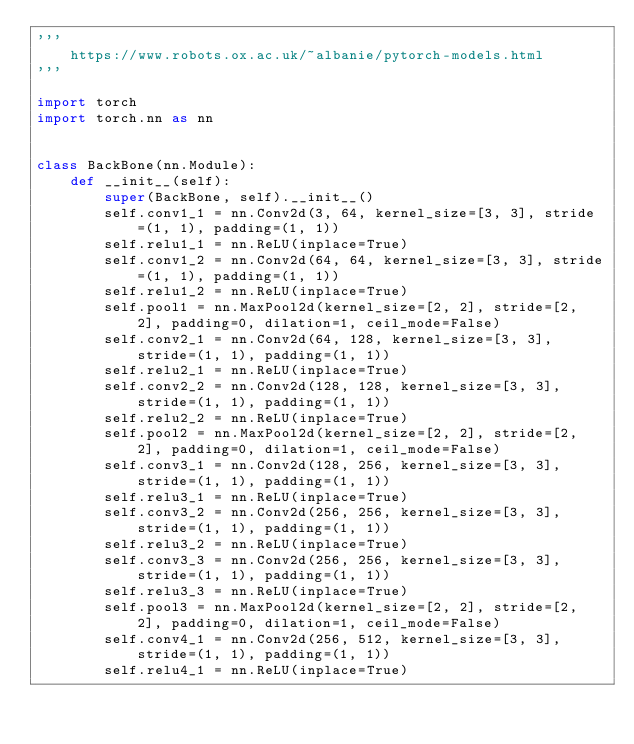Convert code to text. <code><loc_0><loc_0><loc_500><loc_500><_Python_>'''
    https://www.robots.ox.ac.uk/~albanie/pytorch-models.html
'''

import torch
import torch.nn as nn


class BackBone(nn.Module):
    def __init__(self):
        super(BackBone, self).__init__()
        self.conv1_1 = nn.Conv2d(3, 64, kernel_size=[3, 3], stride=(1, 1), padding=(1, 1))
        self.relu1_1 = nn.ReLU(inplace=True)
        self.conv1_2 = nn.Conv2d(64, 64, kernel_size=[3, 3], stride=(1, 1), padding=(1, 1))
        self.relu1_2 = nn.ReLU(inplace=True)
        self.pool1 = nn.MaxPool2d(kernel_size=[2, 2], stride=[2, 2], padding=0, dilation=1, ceil_mode=False)
        self.conv2_1 = nn.Conv2d(64, 128, kernel_size=[3, 3], stride=(1, 1), padding=(1, 1))
        self.relu2_1 = nn.ReLU(inplace=True)
        self.conv2_2 = nn.Conv2d(128, 128, kernel_size=[3, 3], stride=(1, 1), padding=(1, 1))
        self.relu2_2 = nn.ReLU(inplace=True)
        self.pool2 = nn.MaxPool2d(kernel_size=[2, 2], stride=[2, 2], padding=0, dilation=1, ceil_mode=False)
        self.conv3_1 = nn.Conv2d(128, 256, kernel_size=[3, 3], stride=(1, 1), padding=(1, 1))
        self.relu3_1 = nn.ReLU(inplace=True)
        self.conv3_2 = nn.Conv2d(256, 256, kernel_size=[3, 3], stride=(1, 1), padding=(1, 1))
        self.relu3_2 = nn.ReLU(inplace=True)
        self.conv3_3 = nn.Conv2d(256, 256, kernel_size=[3, 3], stride=(1, 1), padding=(1, 1))
        self.relu3_3 = nn.ReLU(inplace=True)
        self.pool3 = nn.MaxPool2d(kernel_size=[2, 2], stride=[2, 2], padding=0, dilation=1, ceil_mode=False)
        self.conv4_1 = nn.Conv2d(256, 512, kernel_size=[3, 3], stride=(1, 1), padding=(1, 1))
        self.relu4_1 = nn.ReLU(inplace=True)</code> 